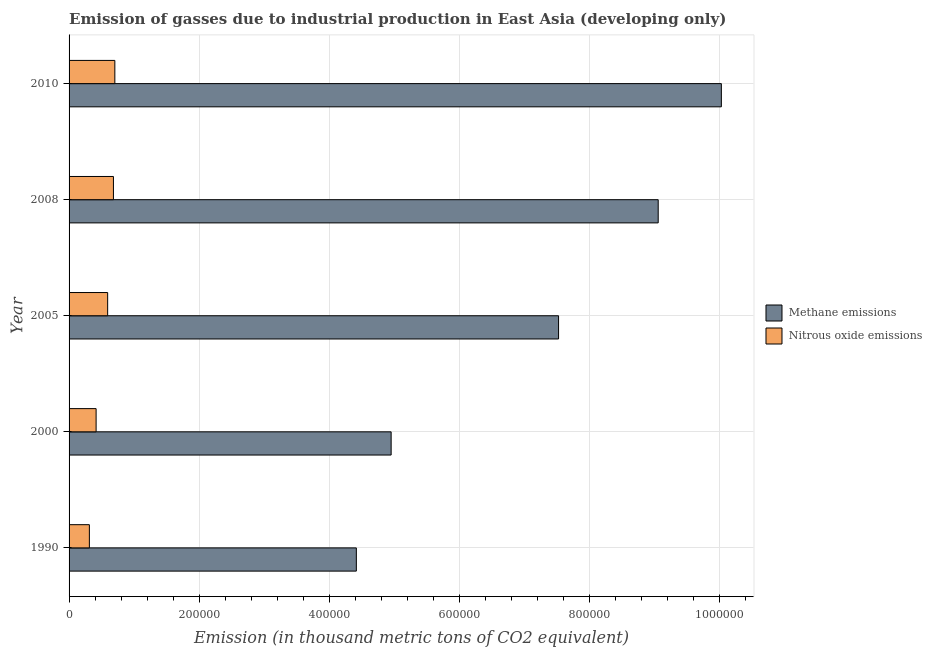How many groups of bars are there?
Your answer should be compact. 5. What is the amount of nitrous oxide emissions in 2005?
Offer a terse response. 5.94e+04. Across all years, what is the maximum amount of methane emissions?
Offer a very short reply. 1.00e+06. Across all years, what is the minimum amount of nitrous oxide emissions?
Offer a very short reply. 3.12e+04. What is the total amount of nitrous oxide emissions in the graph?
Keep it short and to the point. 2.71e+05. What is the difference between the amount of methane emissions in 1990 and that in 2000?
Keep it short and to the point. -5.35e+04. What is the difference between the amount of nitrous oxide emissions in 2005 and the amount of methane emissions in 2010?
Give a very brief answer. -9.44e+05. What is the average amount of methane emissions per year?
Provide a succinct answer. 7.20e+05. In the year 2005, what is the difference between the amount of nitrous oxide emissions and amount of methane emissions?
Your answer should be compact. -6.94e+05. What is the ratio of the amount of methane emissions in 2008 to that in 2010?
Your answer should be compact. 0.9. Is the difference between the amount of nitrous oxide emissions in 1990 and 2000 greater than the difference between the amount of methane emissions in 1990 and 2000?
Give a very brief answer. Yes. What is the difference between the highest and the second highest amount of nitrous oxide emissions?
Provide a succinct answer. 2177.7. What is the difference between the highest and the lowest amount of nitrous oxide emissions?
Provide a succinct answer. 3.92e+04. What does the 1st bar from the top in 2008 represents?
Give a very brief answer. Nitrous oxide emissions. What does the 2nd bar from the bottom in 2008 represents?
Offer a very short reply. Nitrous oxide emissions. Are all the bars in the graph horizontal?
Offer a terse response. Yes. Does the graph contain any zero values?
Ensure brevity in your answer.  No. Where does the legend appear in the graph?
Make the answer very short. Center right. How are the legend labels stacked?
Give a very brief answer. Vertical. What is the title of the graph?
Ensure brevity in your answer.  Emission of gasses due to industrial production in East Asia (developing only). Does "Lower secondary education" appear as one of the legend labels in the graph?
Provide a short and direct response. No. What is the label or title of the X-axis?
Your answer should be compact. Emission (in thousand metric tons of CO2 equivalent). What is the Emission (in thousand metric tons of CO2 equivalent) in Methane emissions in 1990?
Make the answer very short. 4.42e+05. What is the Emission (in thousand metric tons of CO2 equivalent) of Nitrous oxide emissions in 1990?
Your response must be concise. 3.12e+04. What is the Emission (in thousand metric tons of CO2 equivalent) in Methane emissions in 2000?
Provide a succinct answer. 4.95e+05. What is the Emission (in thousand metric tons of CO2 equivalent) in Nitrous oxide emissions in 2000?
Give a very brief answer. 4.16e+04. What is the Emission (in thousand metric tons of CO2 equivalent) in Methane emissions in 2005?
Ensure brevity in your answer.  7.53e+05. What is the Emission (in thousand metric tons of CO2 equivalent) of Nitrous oxide emissions in 2005?
Your response must be concise. 5.94e+04. What is the Emission (in thousand metric tons of CO2 equivalent) of Methane emissions in 2008?
Offer a very short reply. 9.06e+05. What is the Emission (in thousand metric tons of CO2 equivalent) of Nitrous oxide emissions in 2008?
Give a very brief answer. 6.82e+04. What is the Emission (in thousand metric tons of CO2 equivalent) in Methane emissions in 2010?
Give a very brief answer. 1.00e+06. What is the Emission (in thousand metric tons of CO2 equivalent) of Nitrous oxide emissions in 2010?
Your response must be concise. 7.04e+04. Across all years, what is the maximum Emission (in thousand metric tons of CO2 equivalent) of Methane emissions?
Give a very brief answer. 1.00e+06. Across all years, what is the maximum Emission (in thousand metric tons of CO2 equivalent) in Nitrous oxide emissions?
Your answer should be compact. 7.04e+04. Across all years, what is the minimum Emission (in thousand metric tons of CO2 equivalent) in Methane emissions?
Your answer should be compact. 4.42e+05. Across all years, what is the minimum Emission (in thousand metric tons of CO2 equivalent) of Nitrous oxide emissions?
Your answer should be very brief. 3.12e+04. What is the total Emission (in thousand metric tons of CO2 equivalent) of Methane emissions in the graph?
Provide a succinct answer. 3.60e+06. What is the total Emission (in thousand metric tons of CO2 equivalent) of Nitrous oxide emissions in the graph?
Provide a short and direct response. 2.71e+05. What is the difference between the Emission (in thousand metric tons of CO2 equivalent) in Methane emissions in 1990 and that in 2000?
Ensure brevity in your answer.  -5.35e+04. What is the difference between the Emission (in thousand metric tons of CO2 equivalent) of Nitrous oxide emissions in 1990 and that in 2000?
Offer a very short reply. -1.04e+04. What is the difference between the Emission (in thousand metric tons of CO2 equivalent) in Methane emissions in 1990 and that in 2005?
Provide a succinct answer. -3.11e+05. What is the difference between the Emission (in thousand metric tons of CO2 equivalent) in Nitrous oxide emissions in 1990 and that in 2005?
Your response must be concise. -2.81e+04. What is the difference between the Emission (in thousand metric tons of CO2 equivalent) in Methane emissions in 1990 and that in 2008?
Give a very brief answer. -4.64e+05. What is the difference between the Emission (in thousand metric tons of CO2 equivalent) in Nitrous oxide emissions in 1990 and that in 2008?
Provide a succinct answer. -3.70e+04. What is the difference between the Emission (in thousand metric tons of CO2 equivalent) in Methane emissions in 1990 and that in 2010?
Ensure brevity in your answer.  -5.61e+05. What is the difference between the Emission (in thousand metric tons of CO2 equivalent) of Nitrous oxide emissions in 1990 and that in 2010?
Offer a very short reply. -3.92e+04. What is the difference between the Emission (in thousand metric tons of CO2 equivalent) in Methane emissions in 2000 and that in 2005?
Provide a short and direct response. -2.58e+05. What is the difference between the Emission (in thousand metric tons of CO2 equivalent) of Nitrous oxide emissions in 2000 and that in 2005?
Offer a terse response. -1.78e+04. What is the difference between the Emission (in thousand metric tons of CO2 equivalent) in Methane emissions in 2000 and that in 2008?
Make the answer very short. -4.11e+05. What is the difference between the Emission (in thousand metric tons of CO2 equivalent) in Nitrous oxide emissions in 2000 and that in 2008?
Your answer should be compact. -2.66e+04. What is the difference between the Emission (in thousand metric tons of CO2 equivalent) in Methane emissions in 2000 and that in 2010?
Make the answer very short. -5.08e+05. What is the difference between the Emission (in thousand metric tons of CO2 equivalent) of Nitrous oxide emissions in 2000 and that in 2010?
Offer a very short reply. -2.88e+04. What is the difference between the Emission (in thousand metric tons of CO2 equivalent) of Methane emissions in 2005 and that in 2008?
Your response must be concise. -1.53e+05. What is the difference between the Emission (in thousand metric tons of CO2 equivalent) of Nitrous oxide emissions in 2005 and that in 2008?
Your answer should be compact. -8880.6. What is the difference between the Emission (in thousand metric tons of CO2 equivalent) in Methane emissions in 2005 and that in 2010?
Your answer should be compact. -2.50e+05. What is the difference between the Emission (in thousand metric tons of CO2 equivalent) in Nitrous oxide emissions in 2005 and that in 2010?
Ensure brevity in your answer.  -1.11e+04. What is the difference between the Emission (in thousand metric tons of CO2 equivalent) of Methane emissions in 2008 and that in 2010?
Provide a succinct answer. -9.72e+04. What is the difference between the Emission (in thousand metric tons of CO2 equivalent) of Nitrous oxide emissions in 2008 and that in 2010?
Keep it short and to the point. -2177.7. What is the difference between the Emission (in thousand metric tons of CO2 equivalent) of Methane emissions in 1990 and the Emission (in thousand metric tons of CO2 equivalent) of Nitrous oxide emissions in 2000?
Ensure brevity in your answer.  4.00e+05. What is the difference between the Emission (in thousand metric tons of CO2 equivalent) in Methane emissions in 1990 and the Emission (in thousand metric tons of CO2 equivalent) in Nitrous oxide emissions in 2005?
Keep it short and to the point. 3.83e+05. What is the difference between the Emission (in thousand metric tons of CO2 equivalent) of Methane emissions in 1990 and the Emission (in thousand metric tons of CO2 equivalent) of Nitrous oxide emissions in 2008?
Offer a very short reply. 3.74e+05. What is the difference between the Emission (in thousand metric tons of CO2 equivalent) of Methane emissions in 1990 and the Emission (in thousand metric tons of CO2 equivalent) of Nitrous oxide emissions in 2010?
Your response must be concise. 3.71e+05. What is the difference between the Emission (in thousand metric tons of CO2 equivalent) of Methane emissions in 2000 and the Emission (in thousand metric tons of CO2 equivalent) of Nitrous oxide emissions in 2005?
Make the answer very short. 4.36e+05. What is the difference between the Emission (in thousand metric tons of CO2 equivalent) of Methane emissions in 2000 and the Emission (in thousand metric tons of CO2 equivalent) of Nitrous oxide emissions in 2008?
Keep it short and to the point. 4.27e+05. What is the difference between the Emission (in thousand metric tons of CO2 equivalent) of Methane emissions in 2000 and the Emission (in thousand metric tons of CO2 equivalent) of Nitrous oxide emissions in 2010?
Your answer should be very brief. 4.25e+05. What is the difference between the Emission (in thousand metric tons of CO2 equivalent) in Methane emissions in 2005 and the Emission (in thousand metric tons of CO2 equivalent) in Nitrous oxide emissions in 2008?
Make the answer very short. 6.85e+05. What is the difference between the Emission (in thousand metric tons of CO2 equivalent) of Methane emissions in 2005 and the Emission (in thousand metric tons of CO2 equivalent) of Nitrous oxide emissions in 2010?
Make the answer very short. 6.83e+05. What is the difference between the Emission (in thousand metric tons of CO2 equivalent) of Methane emissions in 2008 and the Emission (in thousand metric tons of CO2 equivalent) of Nitrous oxide emissions in 2010?
Offer a terse response. 8.36e+05. What is the average Emission (in thousand metric tons of CO2 equivalent) of Methane emissions per year?
Your answer should be compact. 7.20e+05. What is the average Emission (in thousand metric tons of CO2 equivalent) in Nitrous oxide emissions per year?
Keep it short and to the point. 5.42e+04. In the year 1990, what is the difference between the Emission (in thousand metric tons of CO2 equivalent) in Methane emissions and Emission (in thousand metric tons of CO2 equivalent) in Nitrous oxide emissions?
Your answer should be compact. 4.11e+05. In the year 2000, what is the difference between the Emission (in thousand metric tons of CO2 equivalent) of Methane emissions and Emission (in thousand metric tons of CO2 equivalent) of Nitrous oxide emissions?
Your response must be concise. 4.54e+05. In the year 2005, what is the difference between the Emission (in thousand metric tons of CO2 equivalent) in Methane emissions and Emission (in thousand metric tons of CO2 equivalent) in Nitrous oxide emissions?
Provide a succinct answer. 6.94e+05. In the year 2008, what is the difference between the Emission (in thousand metric tons of CO2 equivalent) of Methane emissions and Emission (in thousand metric tons of CO2 equivalent) of Nitrous oxide emissions?
Your response must be concise. 8.38e+05. In the year 2010, what is the difference between the Emission (in thousand metric tons of CO2 equivalent) of Methane emissions and Emission (in thousand metric tons of CO2 equivalent) of Nitrous oxide emissions?
Provide a short and direct response. 9.33e+05. What is the ratio of the Emission (in thousand metric tons of CO2 equivalent) in Methane emissions in 1990 to that in 2000?
Your answer should be compact. 0.89. What is the ratio of the Emission (in thousand metric tons of CO2 equivalent) of Nitrous oxide emissions in 1990 to that in 2000?
Offer a very short reply. 0.75. What is the ratio of the Emission (in thousand metric tons of CO2 equivalent) in Methane emissions in 1990 to that in 2005?
Offer a very short reply. 0.59. What is the ratio of the Emission (in thousand metric tons of CO2 equivalent) in Nitrous oxide emissions in 1990 to that in 2005?
Give a very brief answer. 0.53. What is the ratio of the Emission (in thousand metric tons of CO2 equivalent) of Methane emissions in 1990 to that in 2008?
Provide a succinct answer. 0.49. What is the ratio of the Emission (in thousand metric tons of CO2 equivalent) in Nitrous oxide emissions in 1990 to that in 2008?
Your answer should be very brief. 0.46. What is the ratio of the Emission (in thousand metric tons of CO2 equivalent) of Methane emissions in 1990 to that in 2010?
Offer a terse response. 0.44. What is the ratio of the Emission (in thousand metric tons of CO2 equivalent) in Nitrous oxide emissions in 1990 to that in 2010?
Ensure brevity in your answer.  0.44. What is the ratio of the Emission (in thousand metric tons of CO2 equivalent) in Methane emissions in 2000 to that in 2005?
Your answer should be very brief. 0.66. What is the ratio of the Emission (in thousand metric tons of CO2 equivalent) of Nitrous oxide emissions in 2000 to that in 2005?
Make the answer very short. 0.7. What is the ratio of the Emission (in thousand metric tons of CO2 equivalent) of Methane emissions in 2000 to that in 2008?
Your response must be concise. 0.55. What is the ratio of the Emission (in thousand metric tons of CO2 equivalent) in Nitrous oxide emissions in 2000 to that in 2008?
Your response must be concise. 0.61. What is the ratio of the Emission (in thousand metric tons of CO2 equivalent) in Methane emissions in 2000 to that in 2010?
Keep it short and to the point. 0.49. What is the ratio of the Emission (in thousand metric tons of CO2 equivalent) of Nitrous oxide emissions in 2000 to that in 2010?
Ensure brevity in your answer.  0.59. What is the ratio of the Emission (in thousand metric tons of CO2 equivalent) in Methane emissions in 2005 to that in 2008?
Make the answer very short. 0.83. What is the ratio of the Emission (in thousand metric tons of CO2 equivalent) of Nitrous oxide emissions in 2005 to that in 2008?
Your answer should be compact. 0.87. What is the ratio of the Emission (in thousand metric tons of CO2 equivalent) of Methane emissions in 2005 to that in 2010?
Your answer should be compact. 0.75. What is the ratio of the Emission (in thousand metric tons of CO2 equivalent) in Nitrous oxide emissions in 2005 to that in 2010?
Offer a terse response. 0.84. What is the ratio of the Emission (in thousand metric tons of CO2 equivalent) in Methane emissions in 2008 to that in 2010?
Keep it short and to the point. 0.9. What is the ratio of the Emission (in thousand metric tons of CO2 equivalent) of Nitrous oxide emissions in 2008 to that in 2010?
Offer a very short reply. 0.97. What is the difference between the highest and the second highest Emission (in thousand metric tons of CO2 equivalent) of Methane emissions?
Give a very brief answer. 9.72e+04. What is the difference between the highest and the second highest Emission (in thousand metric tons of CO2 equivalent) of Nitrous oxide emissions?
Give a very brief answer. 2177.7. What is the difference between the highest and the lowest Emission (in thousand metric tons of CO2 equivalent) in Methane emissions?
Your answer should be compact. 5.61e+05. What is the difference between the highest and the lowest Emission (in thousand metric tons of CO2 equivalent) in Nitrous oxide emissions?
Ensure brevity in your answer.  3.92e+04. 